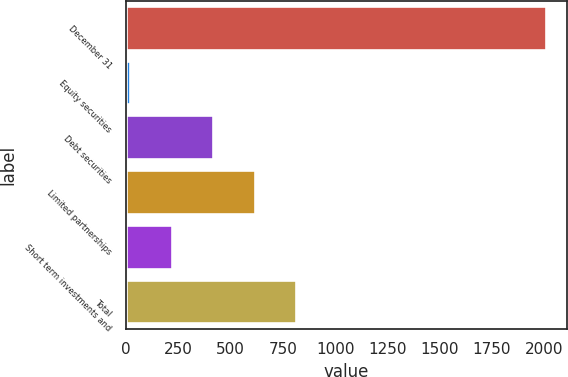<chart> <loc_0><loc_0><loc_500><loc_500><bar_chart><fcel>December 31<fcel>Equity securities<fcel>Debt securities<fcel>Limited partnerships<fcel>Short term investments and<fcel>Total<nl><fcel>2007<fcel>19.1<fcel>416.68<fcel>615.47<fcel>217.89<fcel>814.26<nl></chart> 